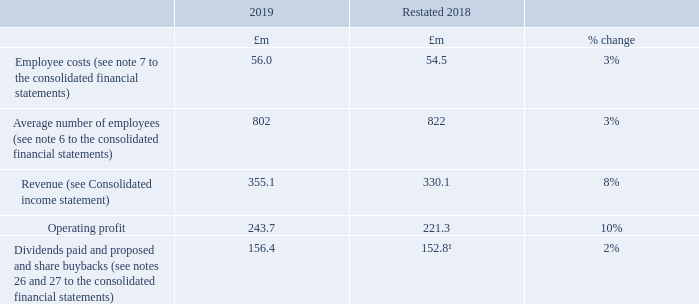Relative importance of the spend on pay
The following table shows the Group’s actual spend on pay for all employees compared to distributions to shareholders. The average number of employees has also been included for context. Revenue and Operating profit have also been disclosed as these are two key measures of Group performance.
1 2018 comparatives have been restated to reflect the adoption of IFRS 9, IFRS 15 and IFRS 16, and to include share buybacks.
What does the table in the context show? The group’s actual spend on pay for all employees compared to distributions to shareholders. Why has the 2018 figures in the table been restated? To reflect the adoption of ifrs 9, ifrs 15 and ifrs 16, and to include share buybacks. Which items in the table are key measures of Group performance? Revenue, operating profit. In which year were employee costs larger? 56.0>54.5
Answer: 2019. What was the change in employee costs in 2019 from 2018?
Answer scale should be: million. 56.0-54.5
Answer: 1.5. What was the average operating profit in 2018 and 2019?
Answer scale should be: million. (243.7+221.3)/2
Answer: 232.5. 